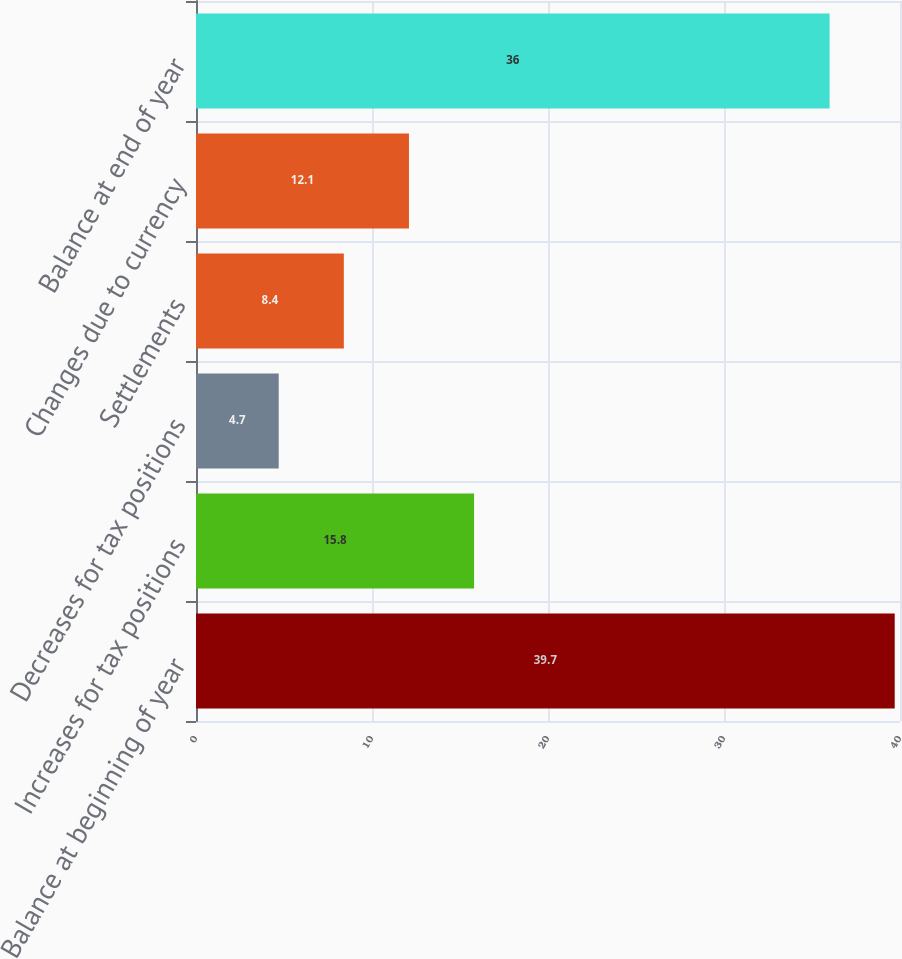<chart> <loc_0><loc_0><loc_500><loc_500><bar_chart><fcel>Balance at beginning of year<fcel>Increases for tax positions<fcel>Decreases for tax positions<fcel>Settlements<fcel>Changes due to currency<fcel>Balance at end of year<nl><fcel>39.7<fcel>15.8<fcel>4.7<fcel>8.4<fcel>12.1<fcel>36<nl></chart> 